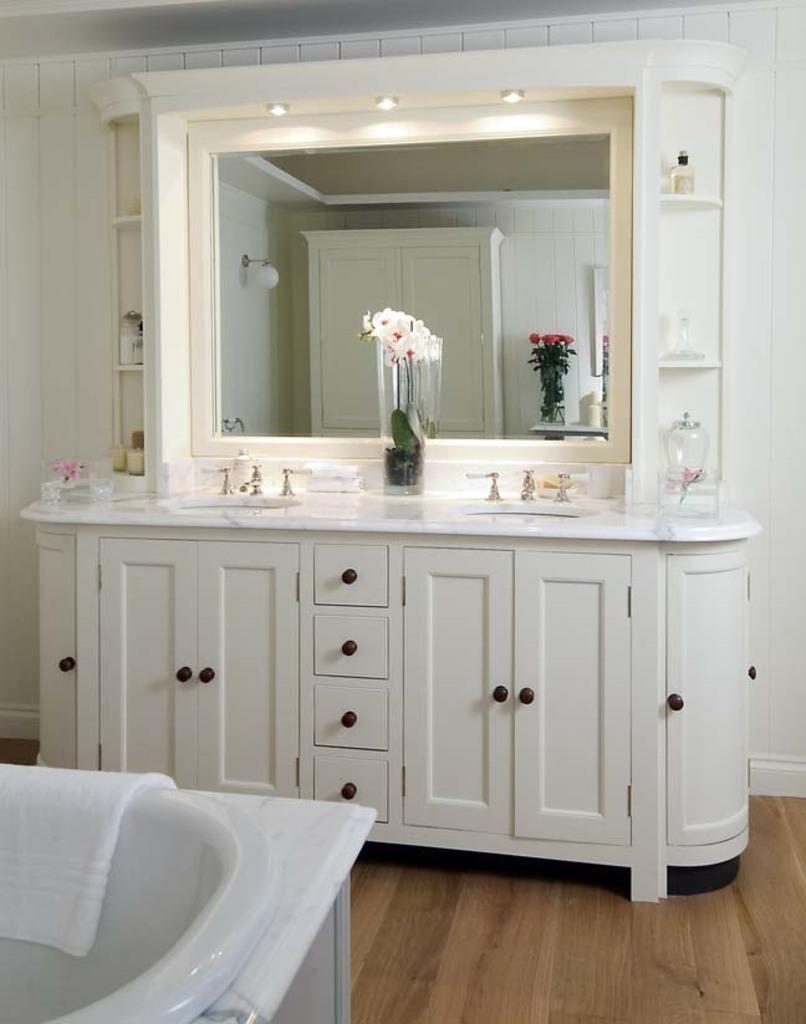In one or two sentences, can you explain what this image depicts? In this image, we can see some cupboards, there is a mirror, we can see a flower pot, there is a wooden floor, we can see a bathtub on the left side bottom, there is a towel in the bathtub. 